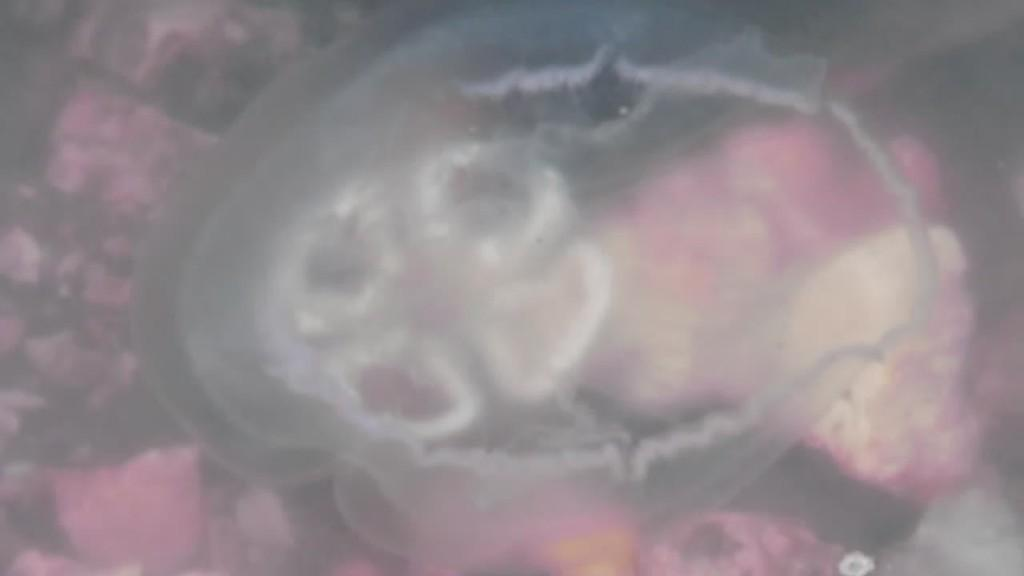What type of material is visible in the image? Biological tissues are visible in the image. What type of story is being told by the creature in the vessel in the image? There is no creature or vessel present in the image; only biological tissues are visible. 